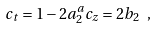Convert formula to latex. <formula><loc_0><loc_0><loc_500><loc_500>c _ { t } = 1 - 2 a _ { 2 } ^ { a } c _ { z } = 2 b _ { 2 } \ ,</formula> 